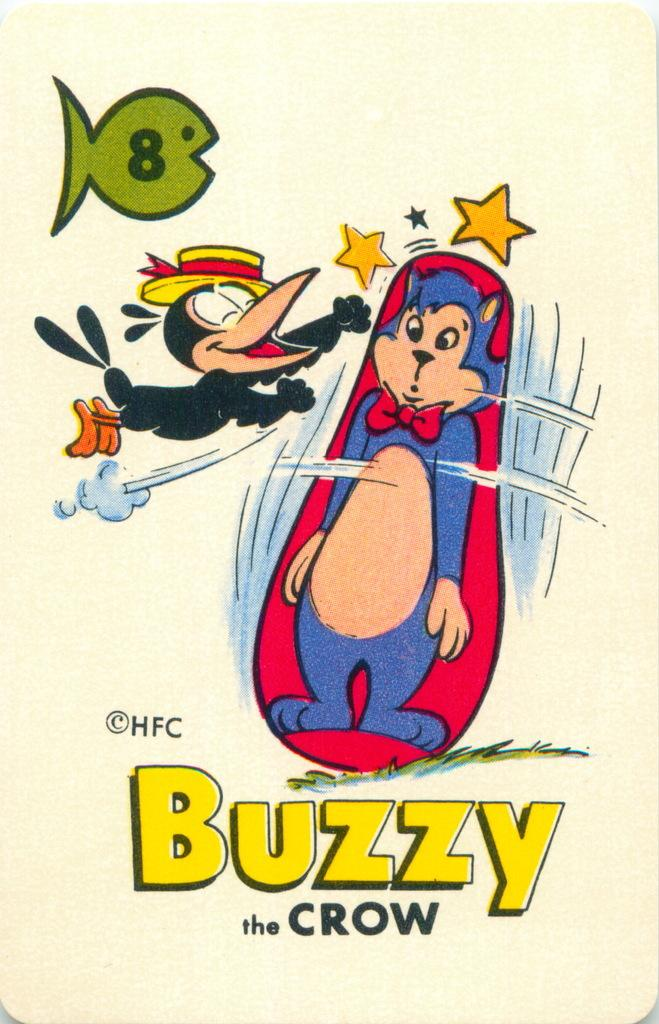<image>
Share a concise interpretation of the image provided. A cartoon bird is punching a cat shaped punching bag in this illustration of Buzzy the Crow. 